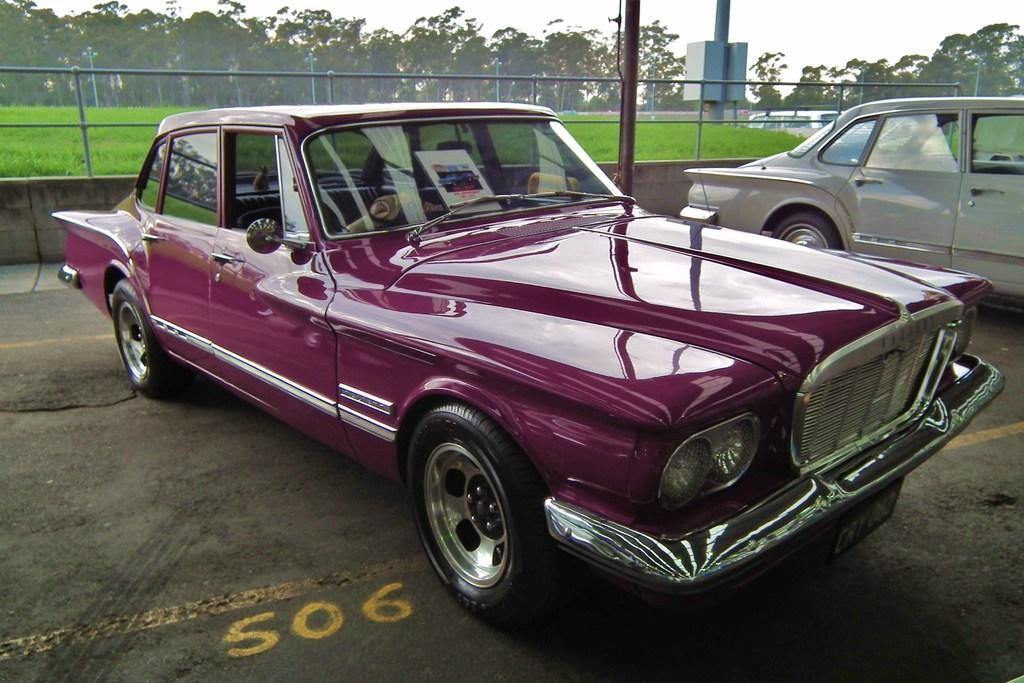What can be seen in the image that is used for transportation? There are vehicles parked in the image. What is located behind the vehicles? There is a railing behind the vehicles. What type of vegetation is present behind the railing? Grass is present behind the railing. What can be seen in the background of the image besides the sky? There are poles and an unspecified object in the background. What is visible at the top of the image? The sky is visible in the background of the image. What type of sheet is being used to cover the boats in the image? There are no boats or sheets present in the image. What type of work is being done by the vehicles in the image? The vehicles are parked, so no work is being done by them in the image. 